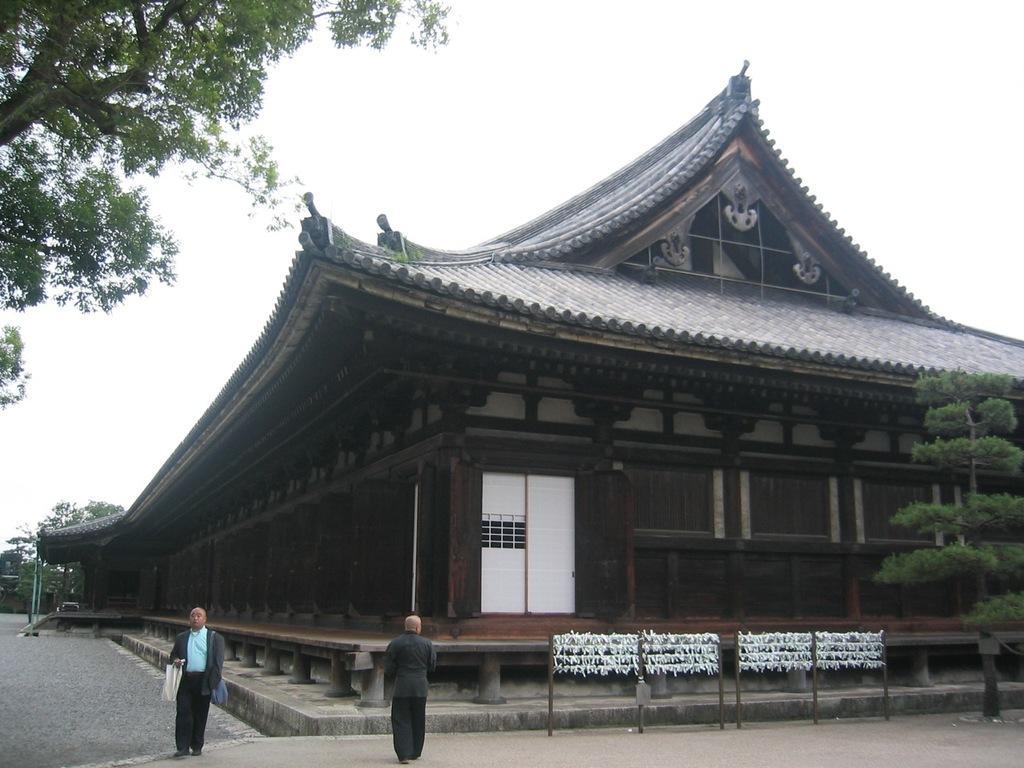Please provide a concise description of this image. In the image we can see temple construction. There are even people wearing clothes. Here we can see a footpath, trees and the white sky. 